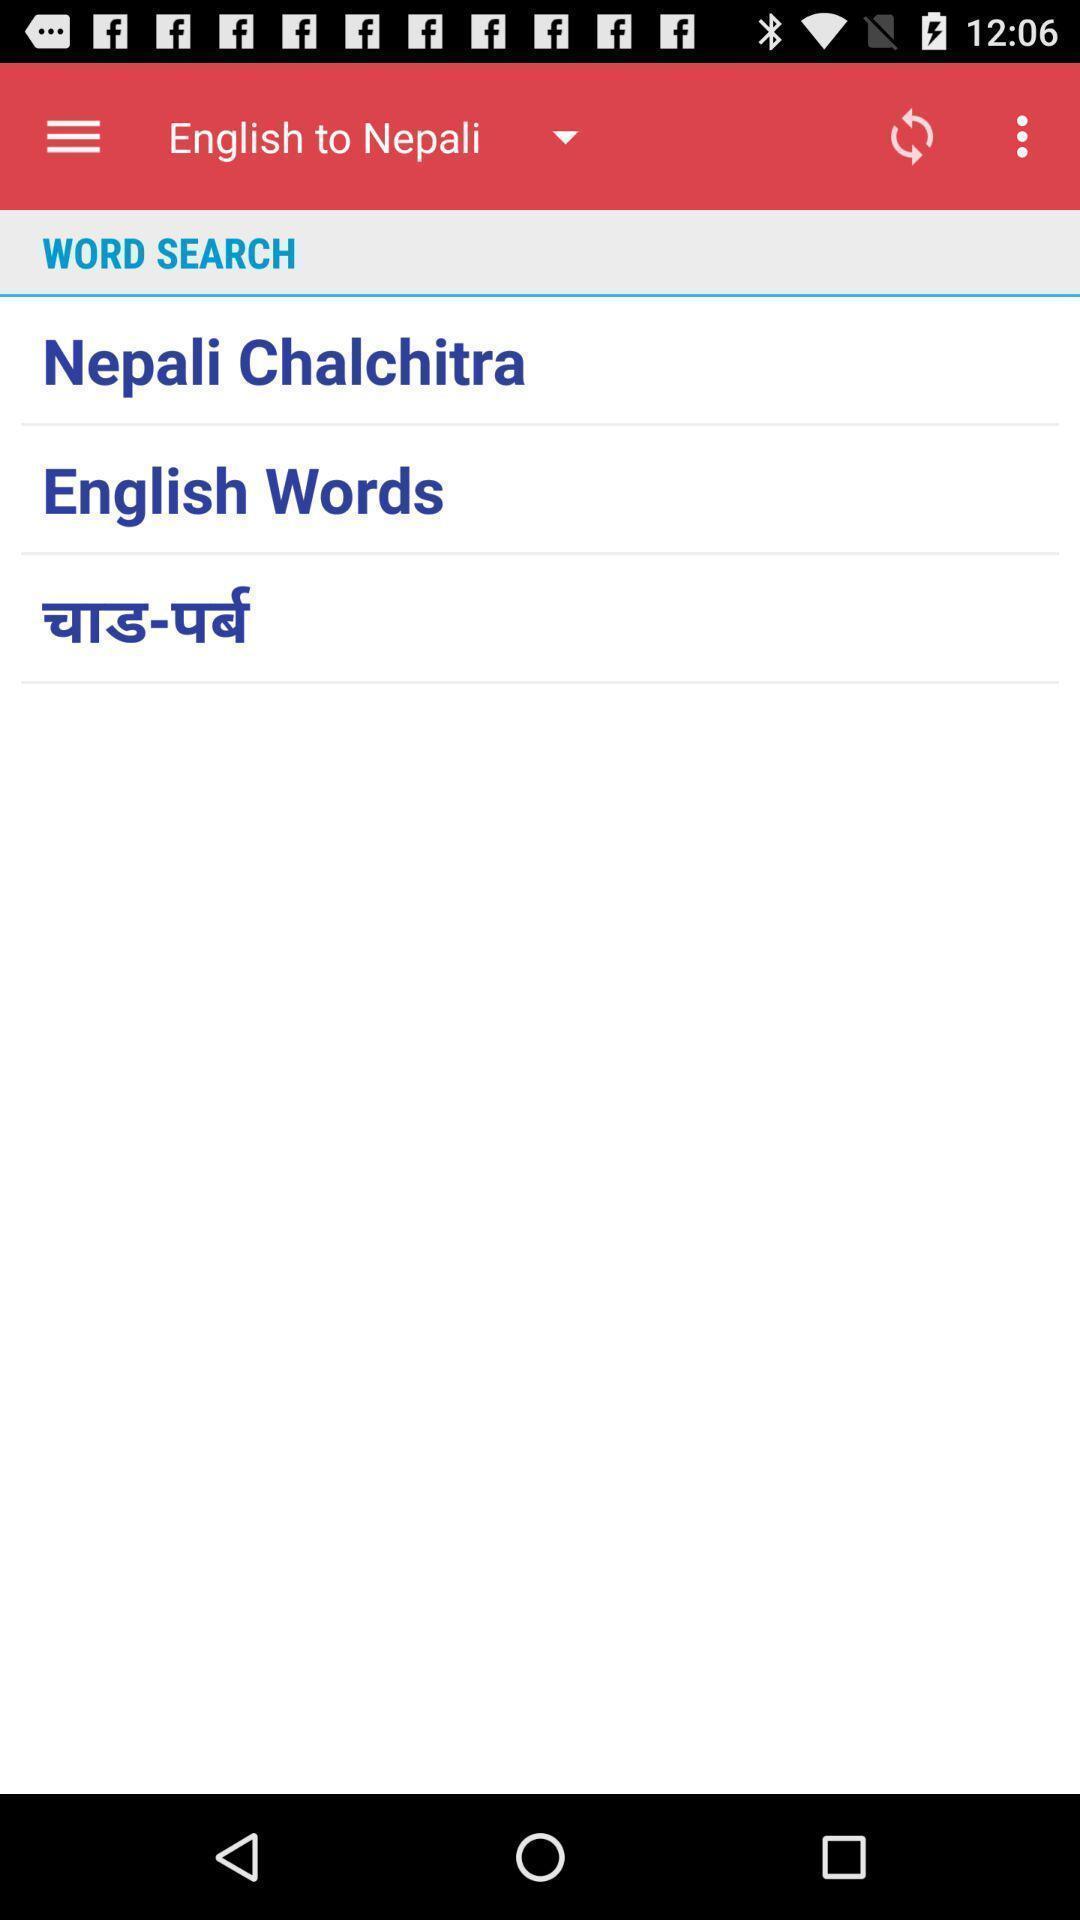Explain what's happening in this screen capture. Page of a language translation application. 